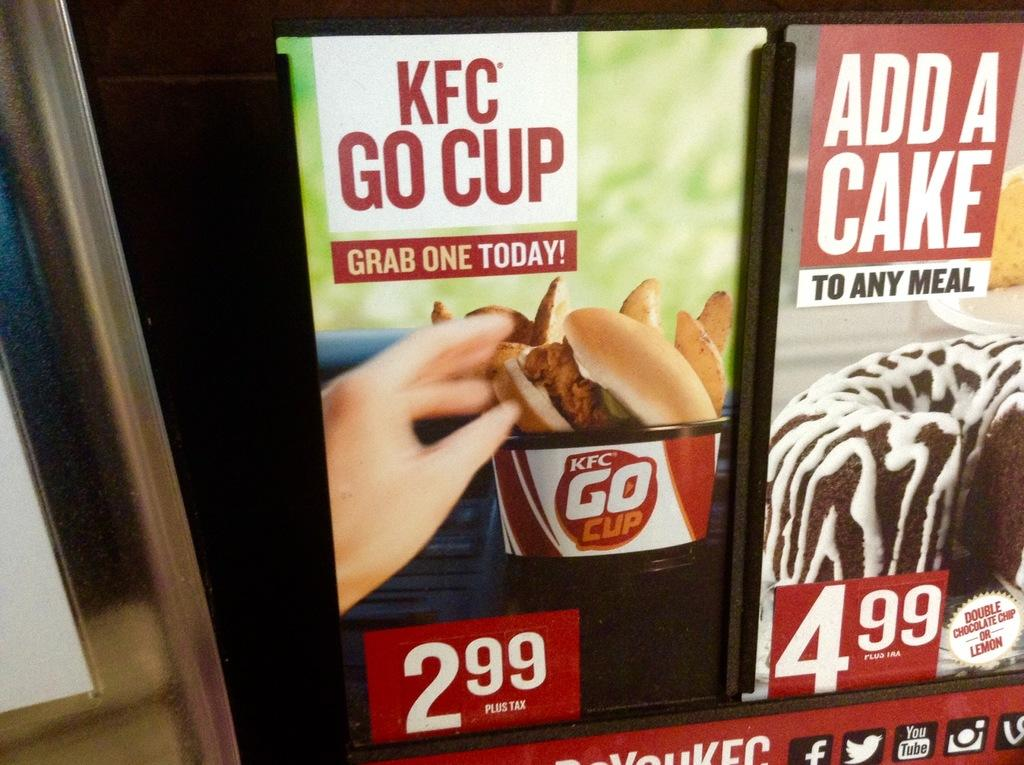What type of structures can be seen in the image? There are posts and a pole in the image. What else is present on these structures? There are posters on the posts and pole. What is depicted on the posters? A person's hand and food items are depicted on the posters. How would you describe the overall appearance of the image? The background of the image is dark. Can you see any smoke coming from the person's hand on the posters? There is no smoke depicted on the posters; only a person's hand and food items are shown. What type of head is visible on the posters? There is no head depicted on the posters; only a person's hand and food items are shown. 